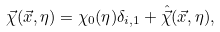Convert formula to latex. <formula><loc_0><loc_0><loc_500><loc_500>\vec { \chi } ( \vec { x } , \eta ) = \chi _ { 0 } ( \eta ) \delta _ { i , 1 } + { \hat { \vec { \chi } } } ( \vec { x } , \eta ) ,</formula> 